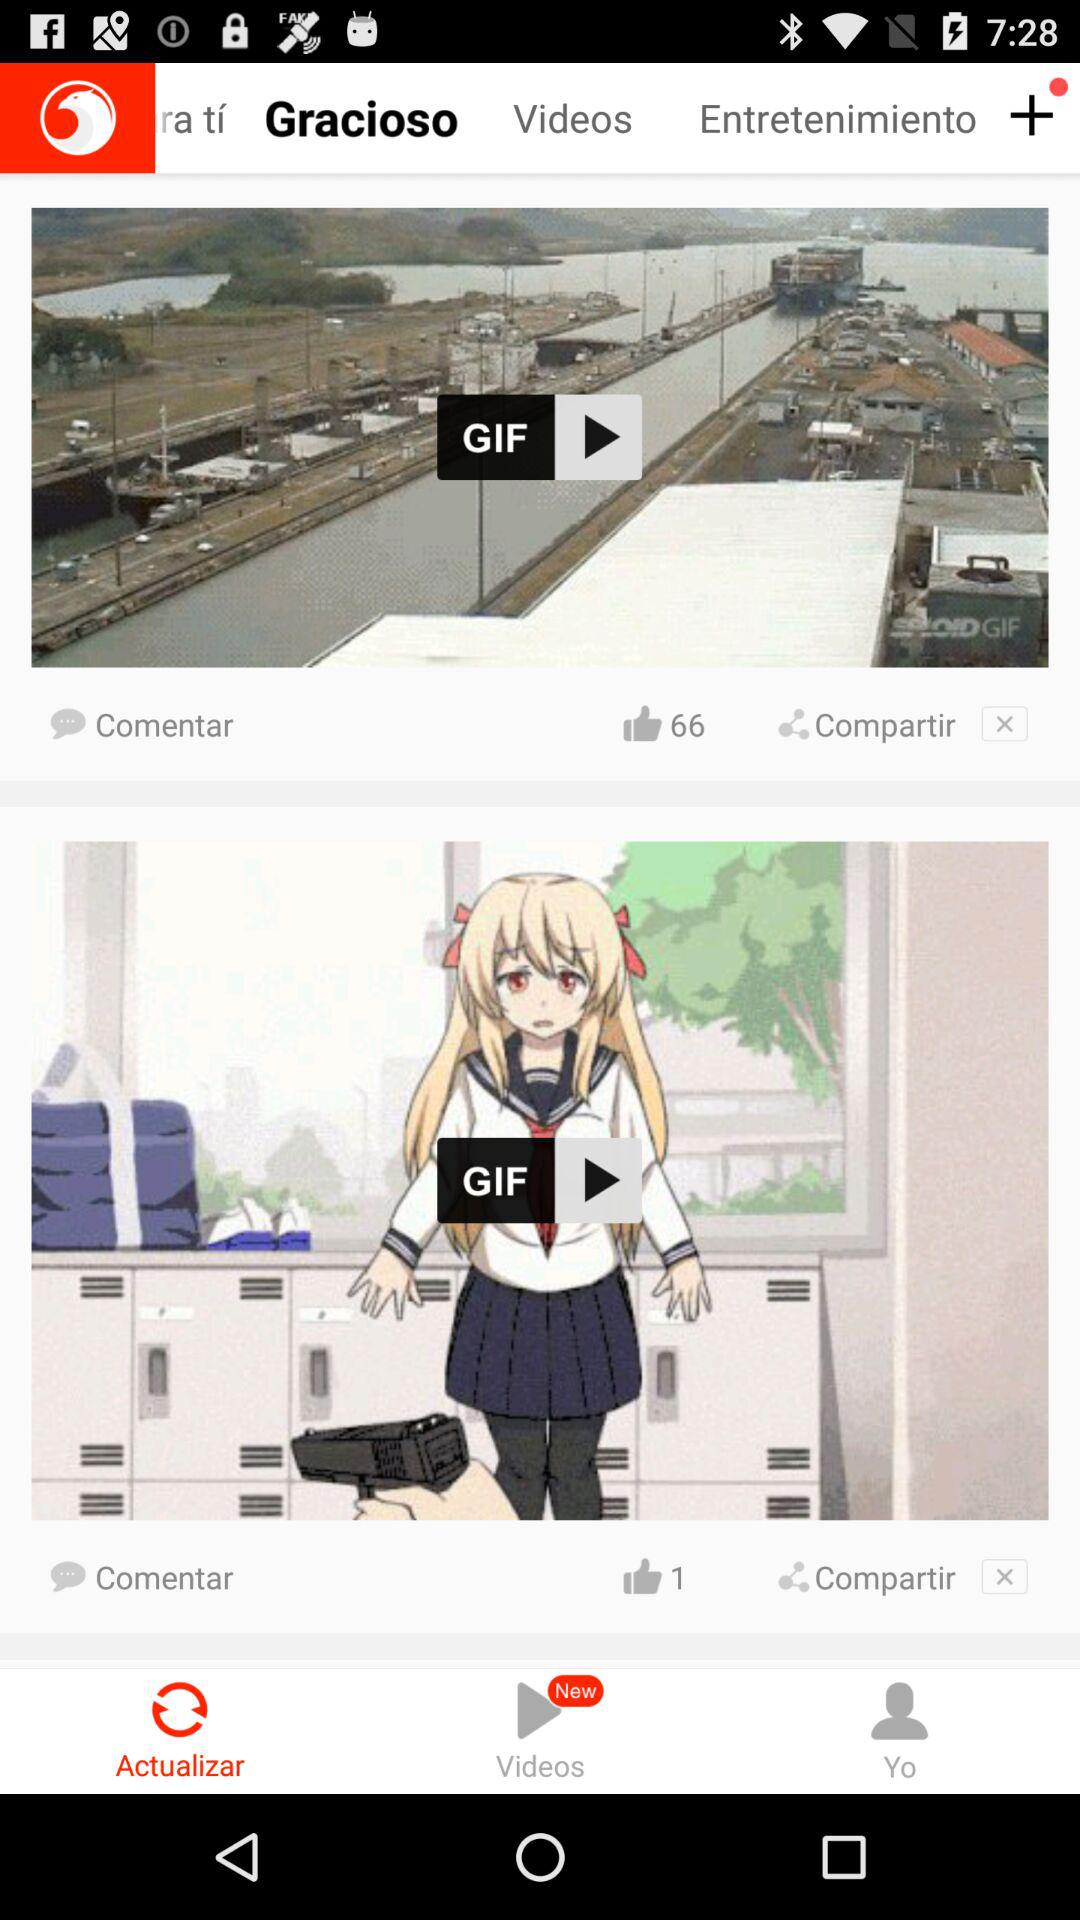How many more thumbs up does the first video have than the second video?
Answer the question using a single word or phrase. 65 